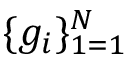<formula> <loc_0><loc_0><loc_500><loc_500>\{ g _ { i } \} _ { 1 = 1 } ^ { N }</formula> 